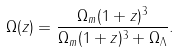Convert formula to latex. <formula><loc_0><loc_0><loc_500><loc_500>\Omega ( z ) = \frac { \Omega _ { m } ( 1 + z ) ^ { 3 } } { \Omega _ { m } ( 1 + z ) ^ { 3 } + \Omega _ { \Lambda } } .</formula> 